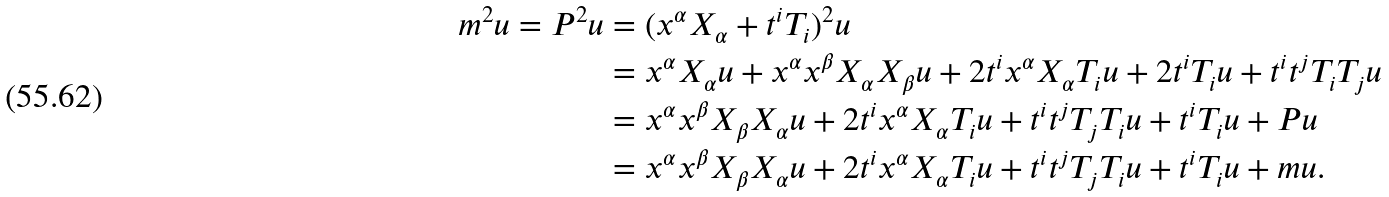<formula> <loc_0><loc_0><loc_500><loc_500>m ^ { 2 } u = P ^ { 2 } u & = ( x ^ { \alpha } X _ { \alpha } + t ^ { i } T _ { i } ) ^ { 2 } u \\ & = x ^ { \alpha } X _ { \alpha } u + x ^ { \alpha } x ^ { \beta } X _ { \alpha } X _ { \beta } u + 2 t ^ { i } x ^ { \alpha } X _ { \alpha } T _ { i } u + 2 t ^ { i } T _ { i } u + t ^ { i } t ^ { j } T _ { i } T _ { j } u \\ & = x ^ { \alpha } x ^ { \beta } X _ { \beta } X _ { \alpha } u + 2 t ^ { i } x ^ { \alpha } X _ { \alpha } T _ { i } u + t ^ { i } t ^ { j } T _ { j } T _ { i } u + t ^ { i } T _ { i } u + P u \\ & = x ^ { \alpha } x ^ { \beta } X _ { \beta } X _ { \alpha } u + 2 t ^ { i } x ^ { \alpha } X _ { \alpha } T _ { i } u + t ^ { i } t ^ { j } T _ { j } T _ { i } u + t ^ { i } T _ { i } u + m u .</formula> 